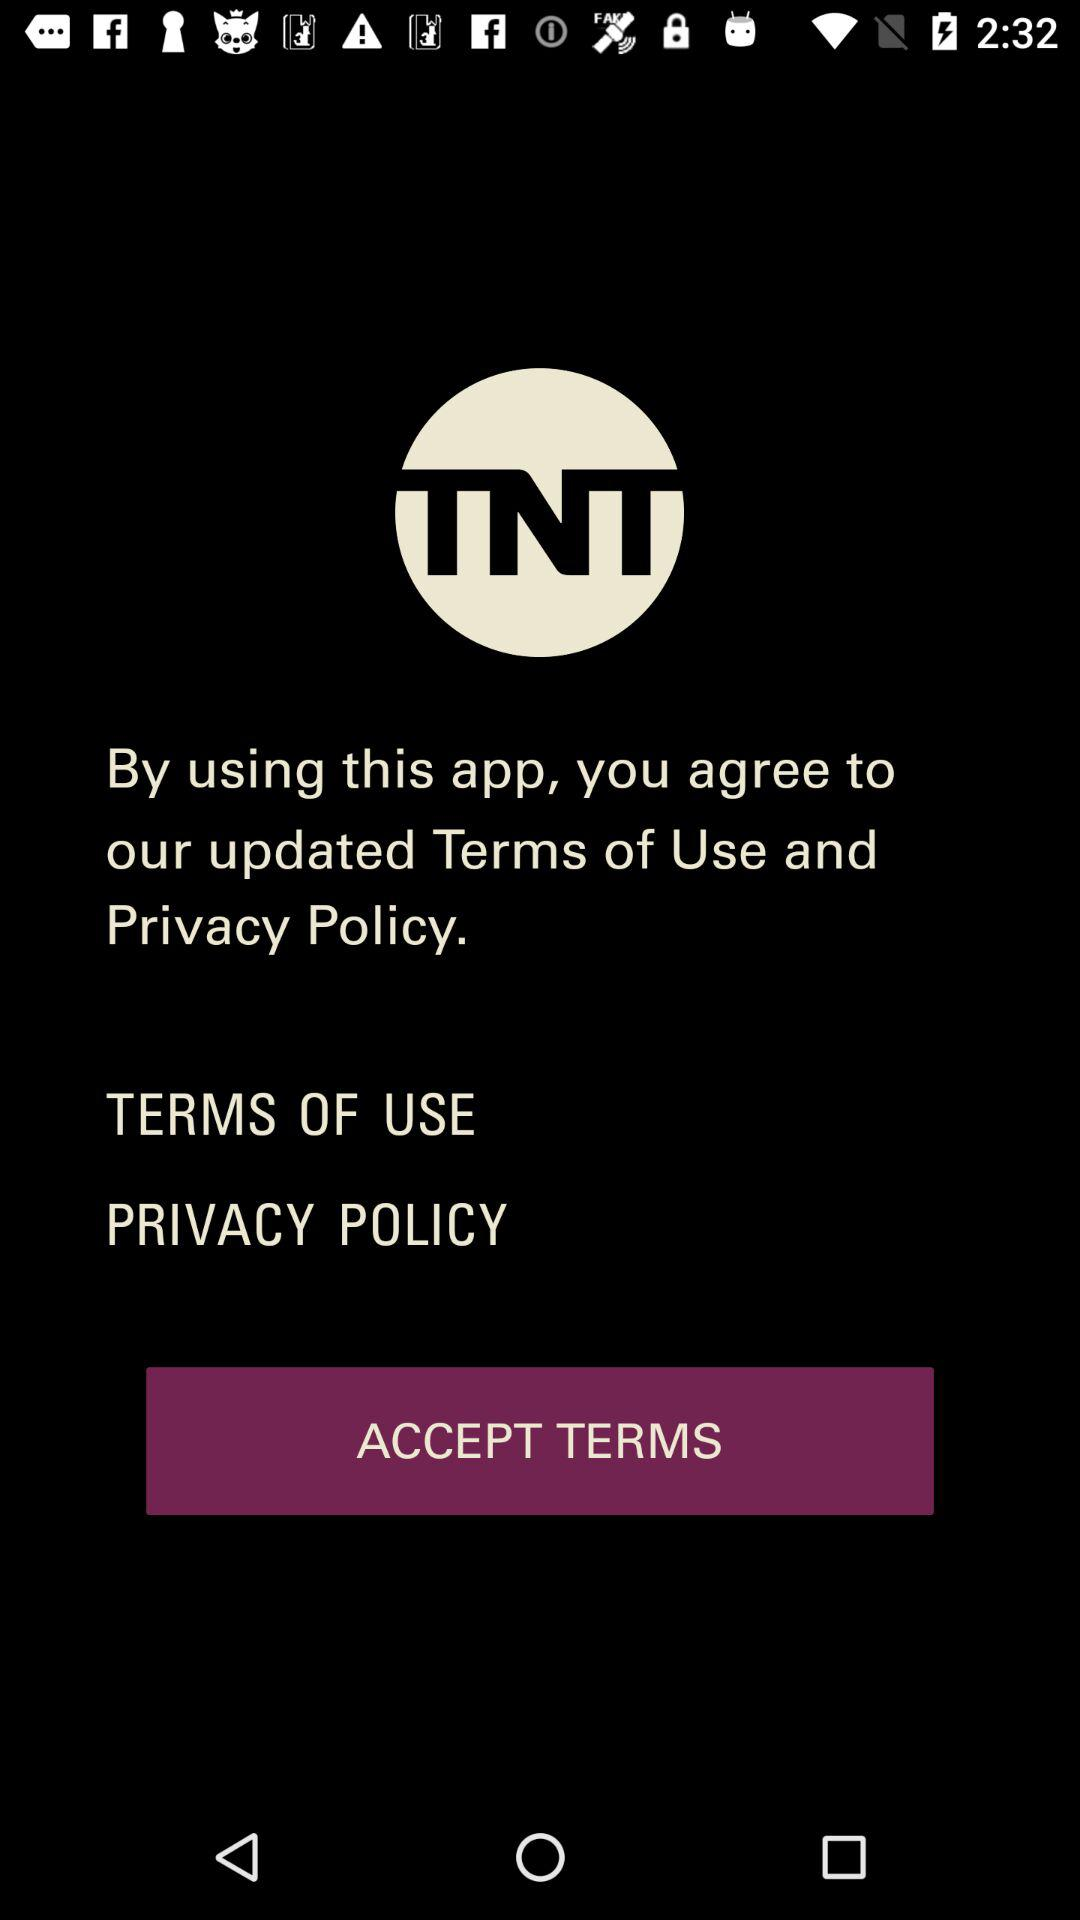What is the name of the application? The application name is "Watch TNT". 